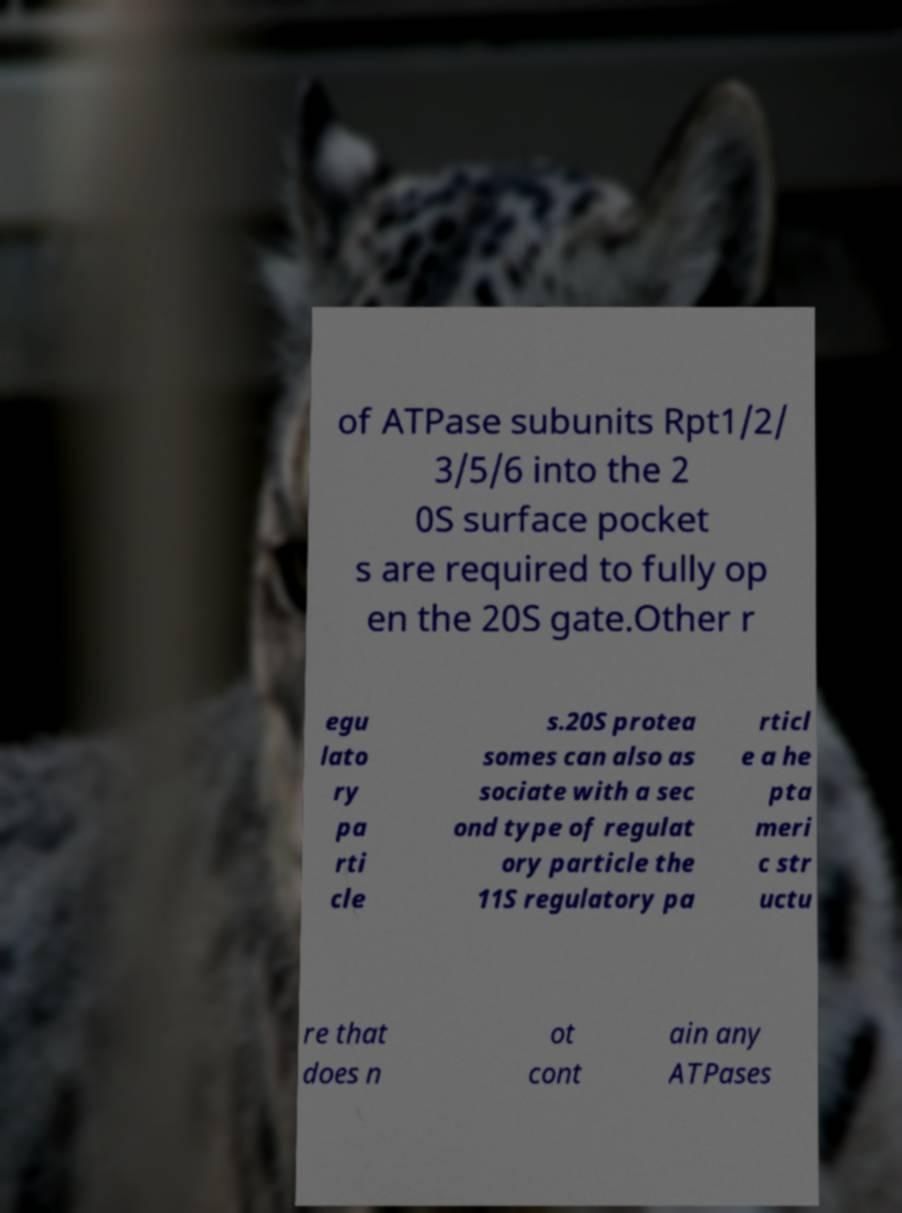For documentation purposes, I need the text within this image transcribed. Could you provide that? of ATPase subunits Rpt1/2/ 3/5/6 into the 2 0S surface pocket s are required to fully op en the 20S gate.Other r egu lato ry pa rti cle s.20S protea somes can also as sociate with a sec ond type of regulat ory particle the 11S regulatory pa rticl e a he pta meri c str uctu re that does n ot cont ain any ATPases 